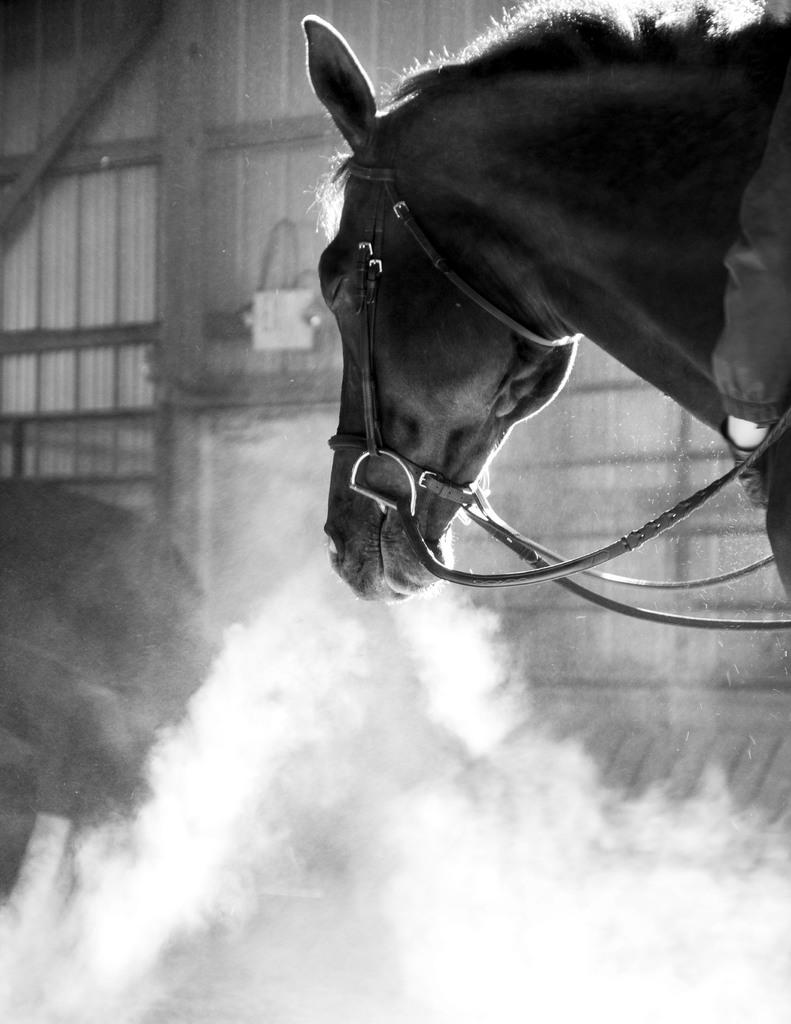What is the color scheme of the image? The image is black and white. Where is the horse located in the image? The horse is in the top right of the image. What can be seen at the bottom of the image? There is smoke at the bottom of the image. How many sisters are standing next to the horse in the image? There are no sisters present in the image; it only features a horse and smoke. What type of dress is the grandmother wearing in the image? There is no grandmother or dress present in the image. 